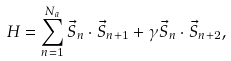<formula> <loc_0><loc_0><loc_500><loc_500>H = \sum _ { n = 1 } ^ { N _ { a } } \vec { S } _ { n } \cdot \vec { S } _ { n + 1 } + \gamma \vec { S } _ { n } \cdot \vec { S } _ { n + 2 } ,</formula> 